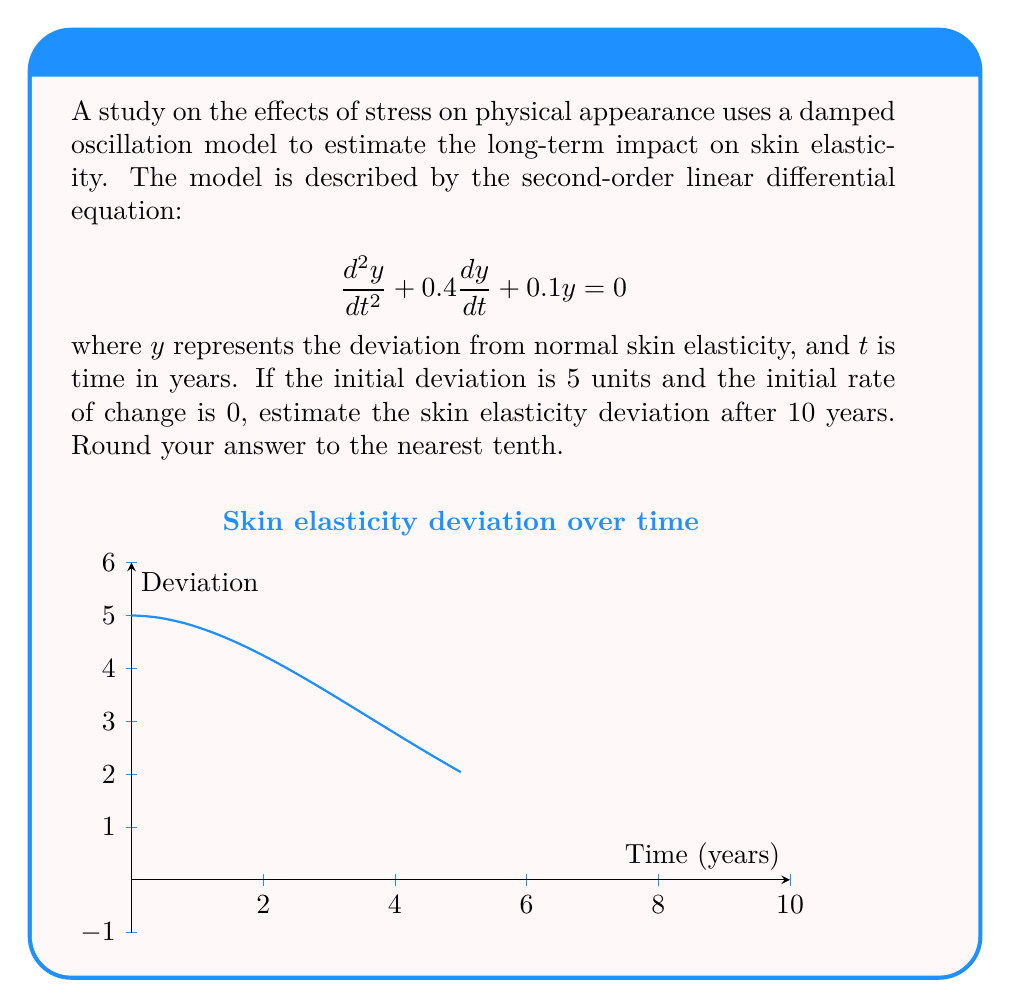What is the answer to this math problem? To solve this problem, we'll follow these steps:

1) The general solution for this damped oscillation model is:

   $$y(t) = e^{-\lambda t}(A\cos(\omega t) + B\sin(\omega t))$$

2) We need to find $\lambda$ and $\omega$. From the given equation:
   
   $$\lambda = 0.2$$ (half of the coefficient of $\frac{dy}{dt}$)
   $$\omega = \sqrt{0.1 - 0.2^2} = 0.2449$$

3) Now we use the initial conditions to find $A$ and $B$:
   
   $y(0) = 5$, so $A = 5$
   $y'(0) = 0$, which gives us $B = \frac{\lambda A}{\omega} = 4.0825$

4) Our specific solution is:

   $$y(t) = 5e^{-0.2t}(\cos(0.2449t) + 0.8165\sin(0.2449t))$$

5) To find $y(10)$, we substitute $t = 10$:

   $$y(10) = 5e^{-2}(\cos(2.449) + 0.8165\sin(2.449))$$

6) Calculating this:

   $$y(10) = 5 * 0.1353 * (-0.7787 + 0.8165 * 0.6273) = 0.3684$$

7) Rounding to the nearest tenth:

   $$y(10) \approx 0.4$$
Answer: 0.4 units 